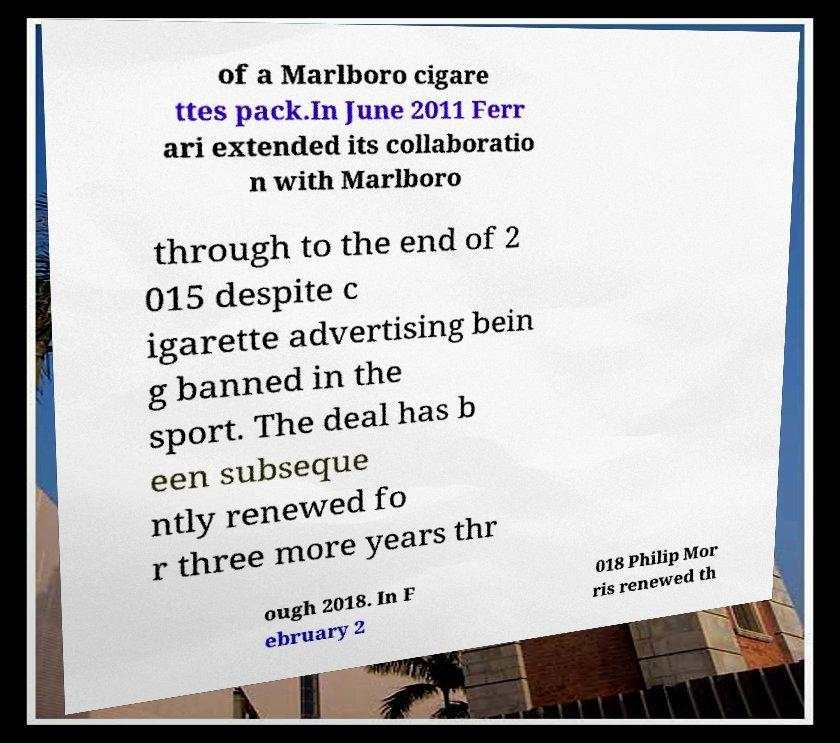Please identify and transcribe the text found in this image. of a Marlboro cigare ttes pack.In June 2011 Ferr ari extended its collaboratio n with Marlboro through to the end of 2 015 despite c igarette advertising bein g banned in the sport. The deal has b een subseque ntly renewed fo r three more years thr ough 2018. In F ebruary 2 018 Philip Mor ris renewed th 